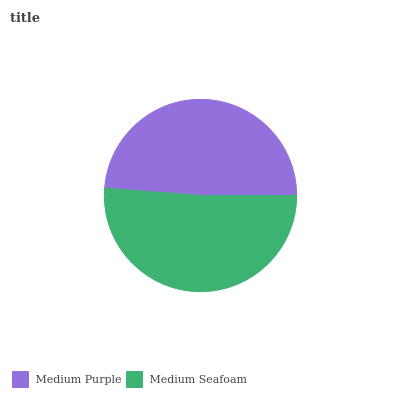Is Medium Purple the minimum?
Answer yes or no. Yes. Is Medium Seafoam the maximum?
Answer yes or no. Yes. Is Medium Seafoam the minimum?
Answer yes or no. No. Is Medium Seafoam greater than Medium Purple?
Answer yes or no. Yes. Is Medium Purple less than Medium Seafoam?
Answer yes or no. Yes. Is Medium Purple greater than Medium Seafoam?
Answer yes or no. No. Is Medium Seafoam less than Medium Purple?
Answer yes or no. No. Is Medium Seafoam the high median?
Answer yes or no. Yes. Is Medium Purple the low median?
Answer yes or no. Yes. Is Medium Purple the high median?
Answer yes or no. No. Is Medium Seafoam the low median?
Answer yes or no. No. 